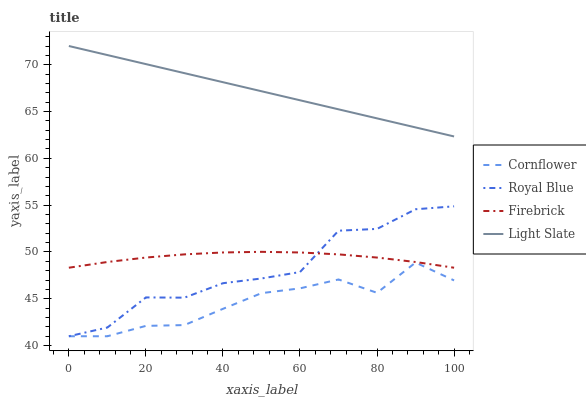Does Cornflower have the minimum area under the curve?
Answer yes or no. Yes. Does Light Slate have the maximum area under the curve?
Answer yes or no. Yes. Does Firebrick have the minimum area under the curve?
Answer yes or no. No. Does Firebrick have the maximum area under the curve?
Answer yes or no. No. Is Light Slate the smoothest?
Answer yes or no. Yes. Is Royal Blue the roughest?
Answer yes or no. Yes. Is Cornflower the smoothest?
Answer yes or no. No. Is Cornflower the roughest?
Answer yes or no. No. Does Cornflower have the lowest value?
Answer yes or no. Yes. Does Firebrick have the lowest value?
Answer yes or no. No. Does Light Slate have the highest value?
Answer yes or no. Yes. Does Firebrick have the highest value?
Answer yes or no. No. Is Royal Blue less than Light Slate?
Answer yes or no. Yes. Is Light Slate greater than Cornflower?
Answer yes or no. Yes. Does Royal Blue intersect Firebrick?
Answer yes or no. Yes. Is Royal Blue less than Firebrick?
Answer yes or no. No. Is Royal Blue greater than Firebrick?
Answer yes or no. No. Does Royal Blue intersect Light Slate?
Answer yes or no. No. 